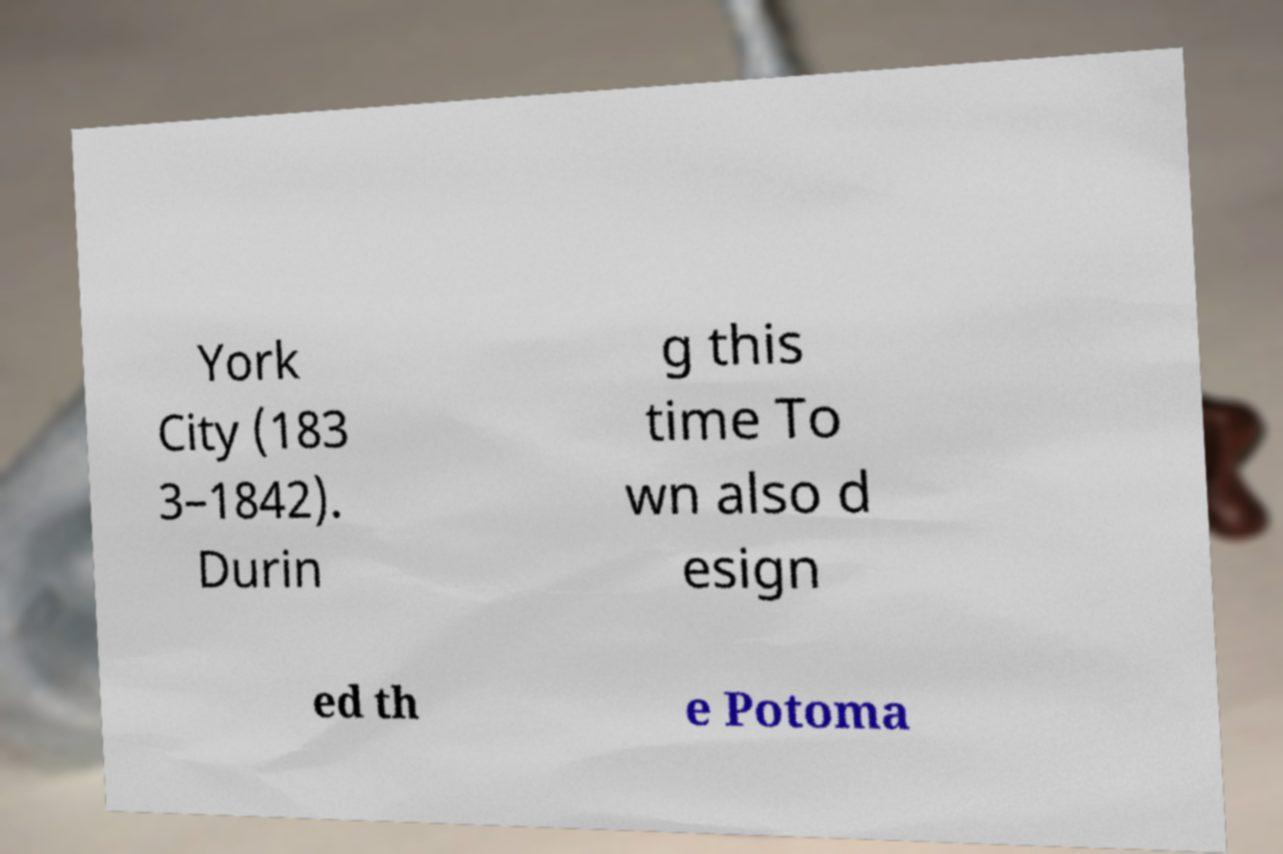What messages or text are displayed in this image? I need them in a readable, typed format. York City (183 3–1842). Durin g this time To wn also d esign ed th e Potoma 